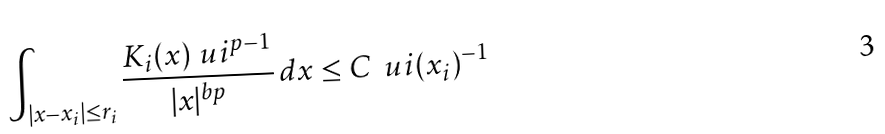Convert formula to latex. <formula><loc_0><loc_0><loc_500><loc_500>\int _ { | x - x _ { i } | \leq r _ { i } } \frac { K _ { i } ( x ) \ u i ^ { p - 1 } } { | x | ^ { b p } } \, d x \leq C \, \ u i ( x _ { i } ) ^ { - 1 }</formula> 